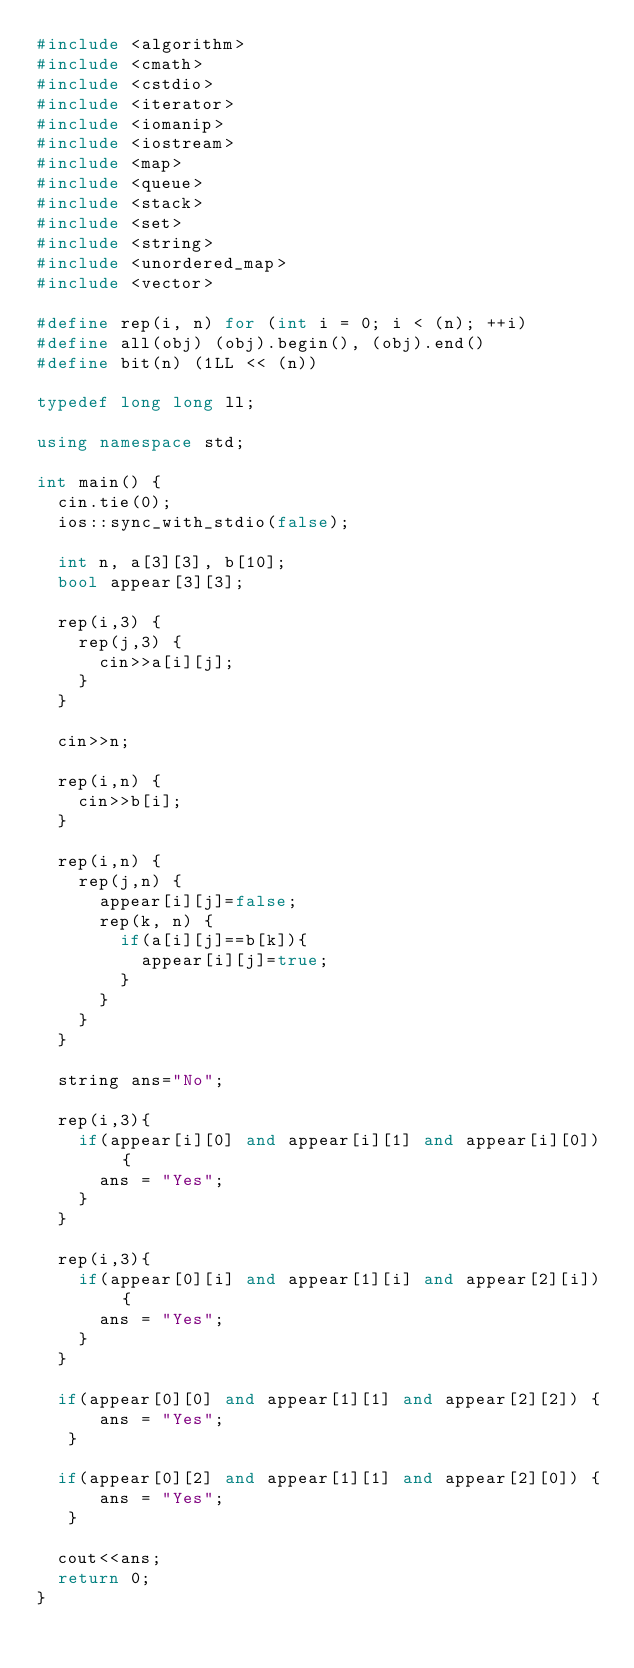<code> <loc_0><loc_0><loc_500><loc_500><_C++_>#include <algorithm>
#include <cmath>
#include <cstdio>
#include <iterator>
#include <iomanip>
#include <iostream>
#include <map>
#include <queue>
#include <stack>
#include <set>
#include <string>
#include <unordered_map>
#include <vector>
 
#define rep(i, n) for (int i = 0; i < (n); ++i)
#define all(obj) (obj).begin(), (obj).end()
#define bit(n) (1LL << (n))
 
typedef long long ll;

using namespace std;

int main() {
  cin.tie(0);
  ios::sync_with_stdio(false);
 
  int n, a[3][3], b[10];
  bool appear[3][3];
  
  rep(i,3) {
    rep(j,3) {
      cin>>a[i][j];
    }
  }
  
  cin>>n;
  
  rep(i,n) {
    cin>>b[i];
  }
  
  rep(i,n) {
    rep(j,n) {
      appear[i][j]=false;
      rep(k, n) {
        if(a[i][j]==b[k]){
          appear[i][j]=true;
        }
      }
    }
  }
  
  string ans="No";

  rep(i,3){
    if(appear[i][0] and appear[i][1] and appear[i][0]) {
      ans = "Yes";
    }
  }
  
  rep(i,3){
    if(appear[0][i] and appear[1][i] and appear[2][i]) {
      ans = "Yes";
    }
  }
  
  if(appear[0][0] and appear[1][1] and appear[2][2]) {
      ans = "Yes";
   }
  
  if(appear[0][2] and appear[1][1] and appear[2][0]) {
      ans = "Yes";
   }
  
  cout<<ans;
  return 0;
}</code> 